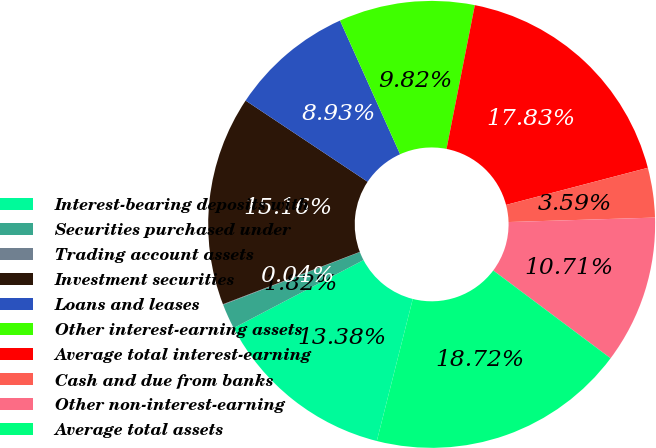<chart> <loc_0><loc_0><loc_500><loc_500><pie_chart><fcel>Interest-bearing deposits with<fcel>Securities purchased under<fcel>Trading account assets<fcel>Investment securities<fcel>Loans and leases<fcel>Other interest-earning assets<fcel>Average total interest-earning<fcel>Cash and due from banks<fcel>Other non-interest-earning<fcel>Average total assets<nl><fcel>13.38%<fcel>1.82%<fcel>0.04%<fcel>15.16%<fcel>8.93%<fcel>9.82%<fcel>17.83%<fcel>3.59%<fcel>10.71%<fcel>18.72%<nl></chart> 